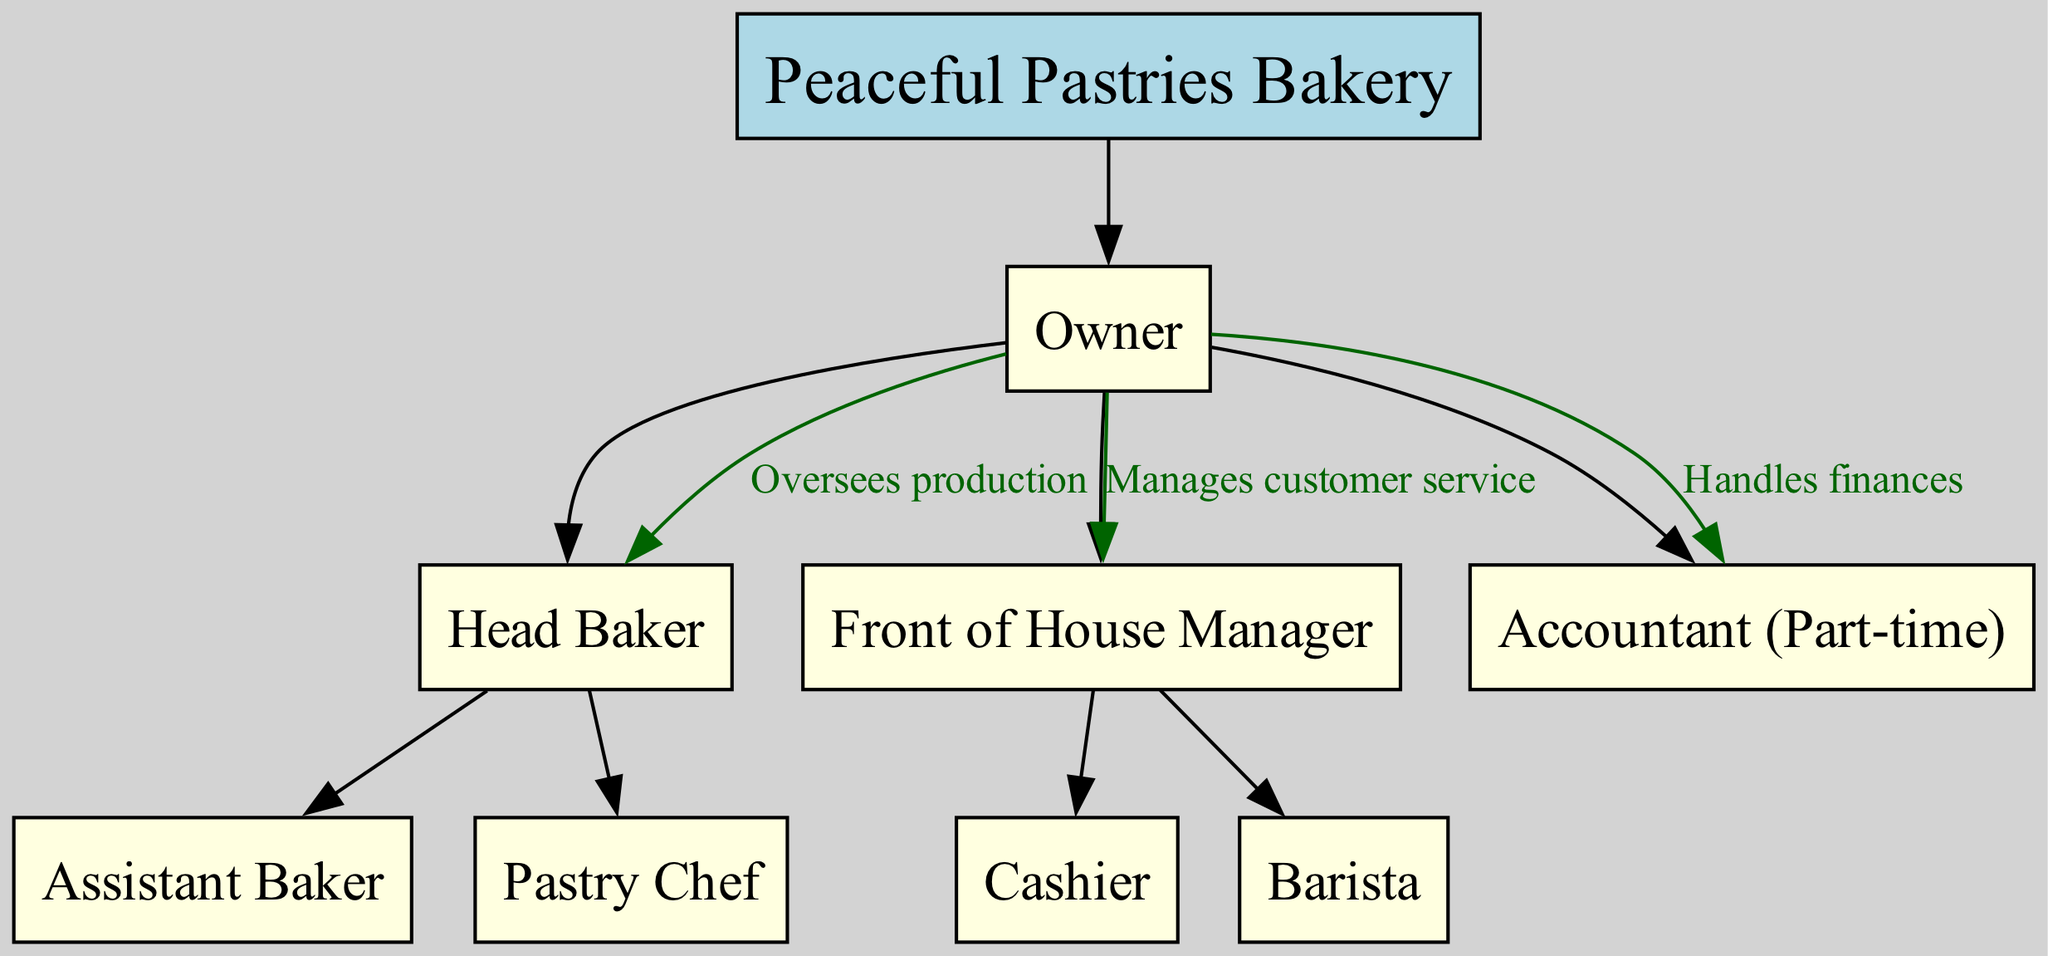What is the root node of the diagram? The root node is the highest level in the organizational chart, which is labeled "Peaceful Pastries Bakery."
Answer: Peaceful Pastries Bakery How many children does the Owner have? The Owner has three children in the diagram: Head Baker, Front of House Manager, and Accountant (Part-time).
Answer: 3 What role is directly responsible for overseeing production? The diagram indicates that the role responsible for overseeing production is the Head Baker, who reports directly to the Owner.
Answer: Head Baker Which role manages customer service? According to the diagram, the Front of House Manager is the role that manages customer service, as shown by the relationship with the Owner.
Answer: Front of House Manager What is the relationship between the Owner and the Accountant (Part-time)? The relationship shown in the diagram indicates that the Owner "Handles finances" related to the Accountant (Part-time), depicting this functional link between them.
Answer: Handles finances Which two roles does the Head Baker oversee? The Head Baker oversees two roles: Assistant Baker and Pastry Chef, as indicated by the structured hierarchy in the diagram.
Answer: Assistant Baker and Pastry Chef How many roles are there under the Front of House Manager? There are two roles under the Front of House Manager: Cashier and Barista, according to the child nodes branching from this manager's position.
Answer: 2 What color is the node representing the Owner? The node for the Owner is filled with light blue color, as indicated in the diagram's styling attributes.
Answer: Light blue Which two roles report directly to the Owner? Both the Head Baker and the Front of House Manager report directly to the Owner, demonstrating their immediate authority in the bakery's operational structure.
Answer: Head Baker and Front of House Manager 